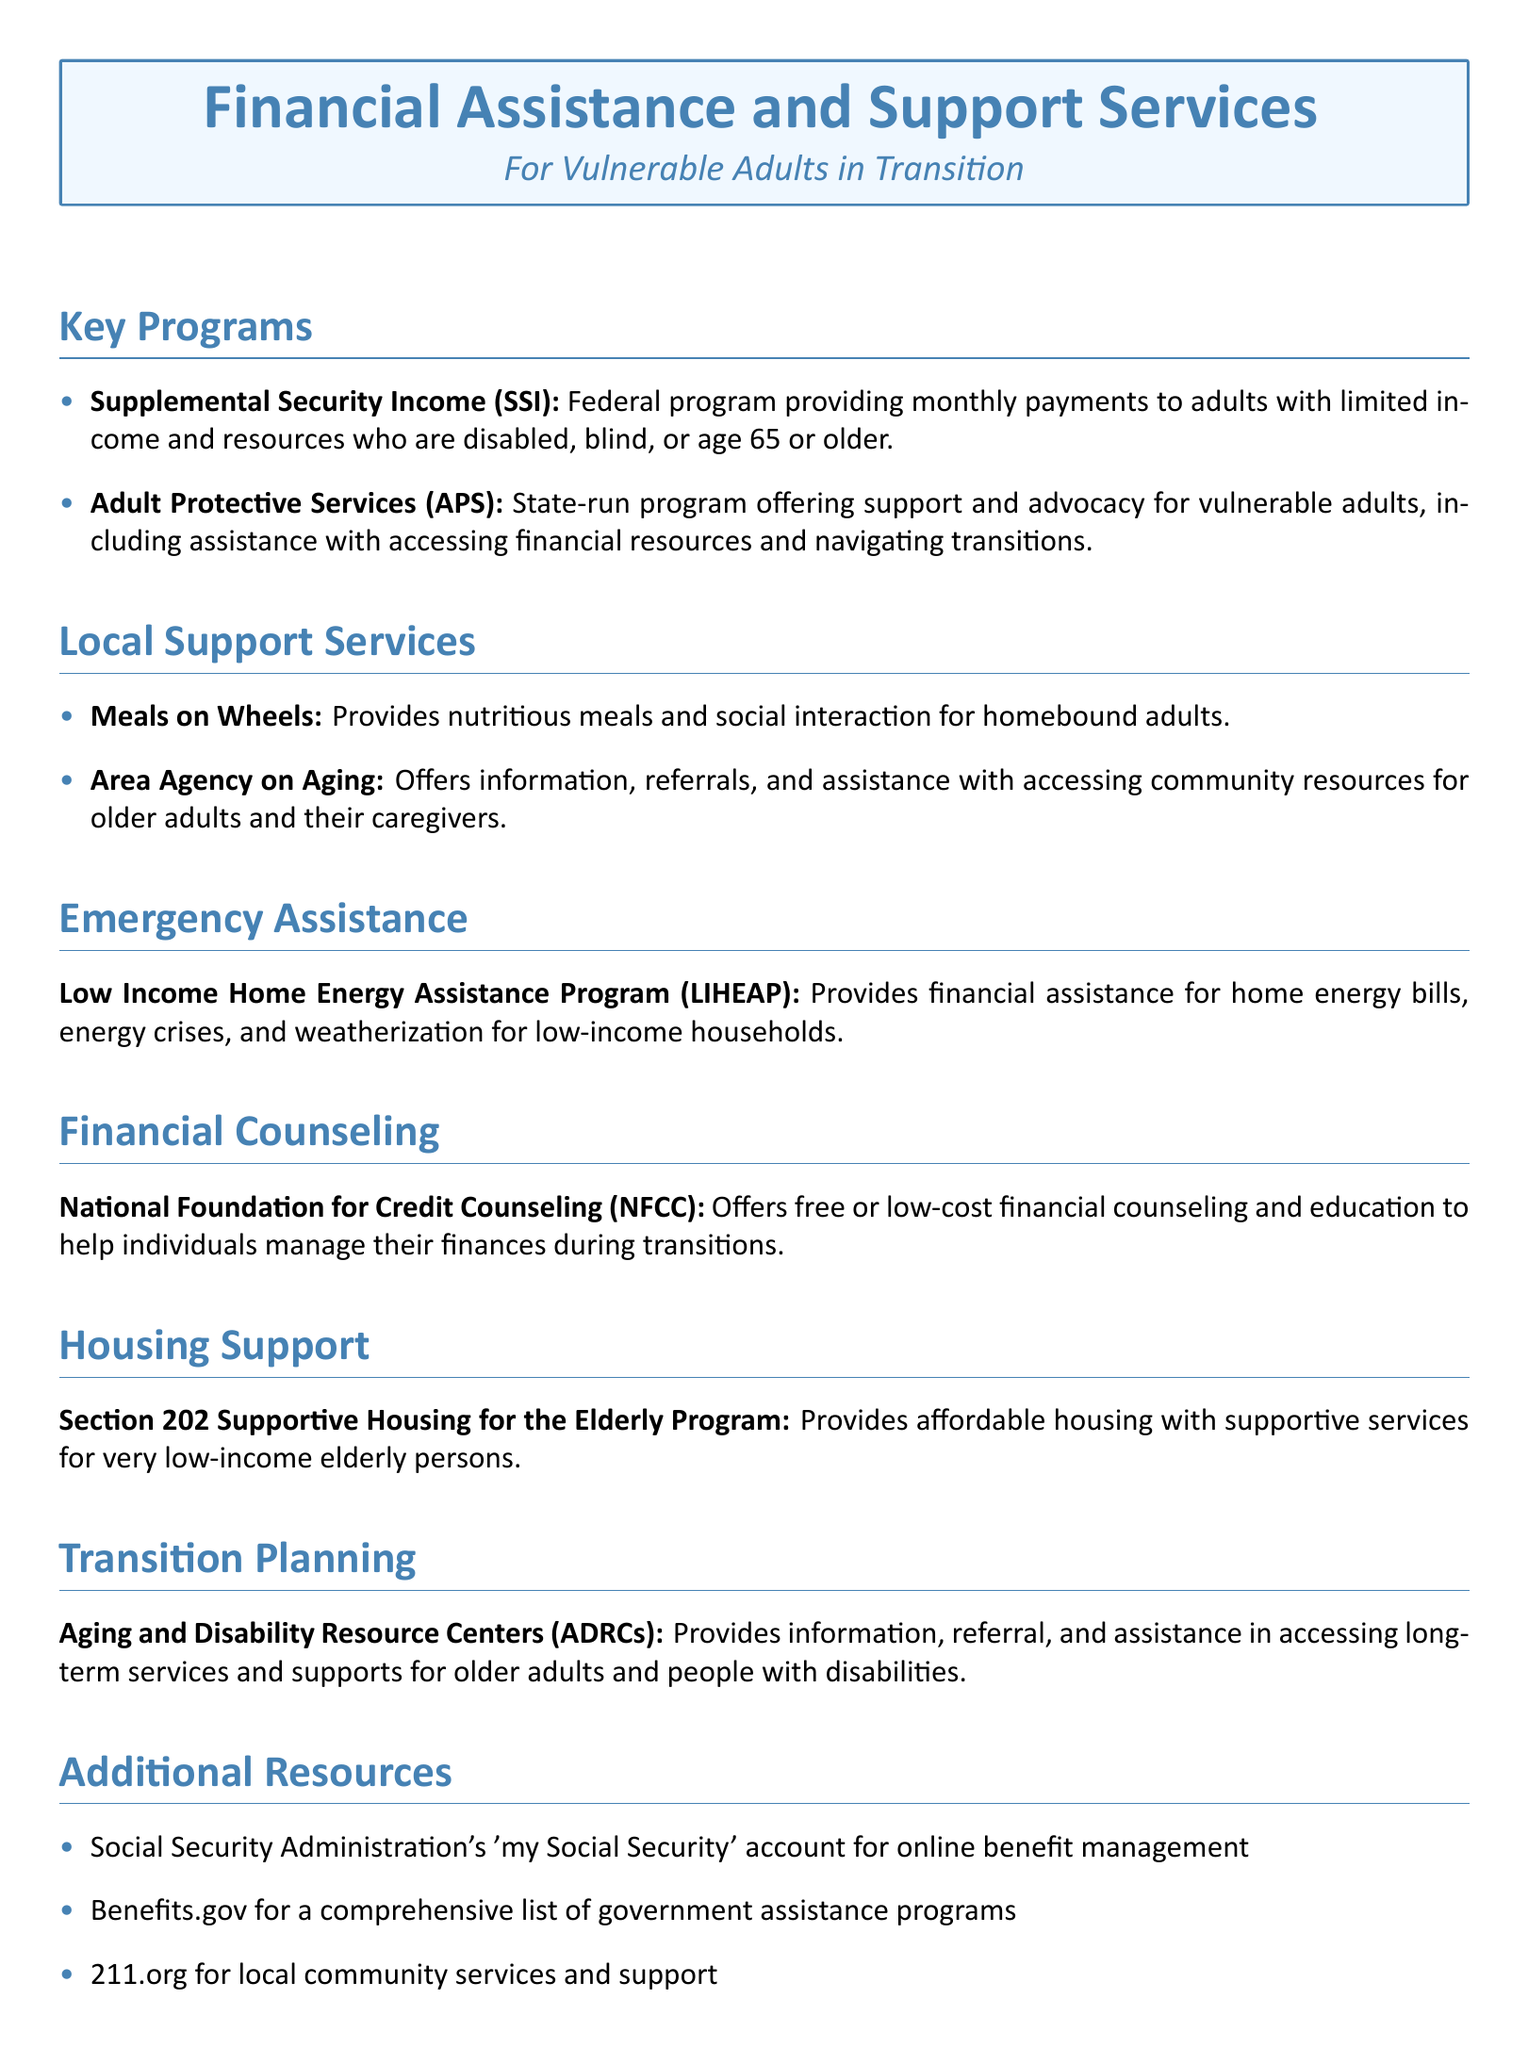What is the SSI program? The SSI program is a federal program providing monthly payments to adults with limited income and resources who are disabled, blind, or age 65 or older.
Answer: Federal program providing monthly payments What does APS stand for? APS stands for Adult Protective Services, which is a state-run program offering support and advocacy for vulnerable adults.
Answer: Adult Protective Services What does Meals on Wheels provide? Meals on Wheels provides nutritious meals and social interaction for homebound adults.
Answer: Nutritious meals and social interaction What is LIHEAP? LIHEAP is the Low Income Home Energy Assistance Program, which provides financial assistance for home energy bills, energy crises, and weatherization for low-income households.
Answer: Low Income Home Energy Assistance Program What type of counseling does NFCC offer? NFCC offers free or low-cost financial counseling and education to help individuals manage their finances during transitions.
Answer: Free or low-cost financial counseling How can you access your Social Security account? You can access your Social Security account through the Social Security Administration's 'my Social Security' account for online benefit management.
Answer: 'my Social Security' account What kind of assistance do ADRCs provide? ADRCs provide information, referral, and assistance in accessing long-term services and supports for older adults and people with disabilities.
Answer: Information, referral, and assistance What type of housing does the Section 202 Program support? The Section 202 Supportive Housing for the Elderly Program provides affordable housing with supportive services for very low-income elderly persons.
Answer: Affordable housing with supportive services 